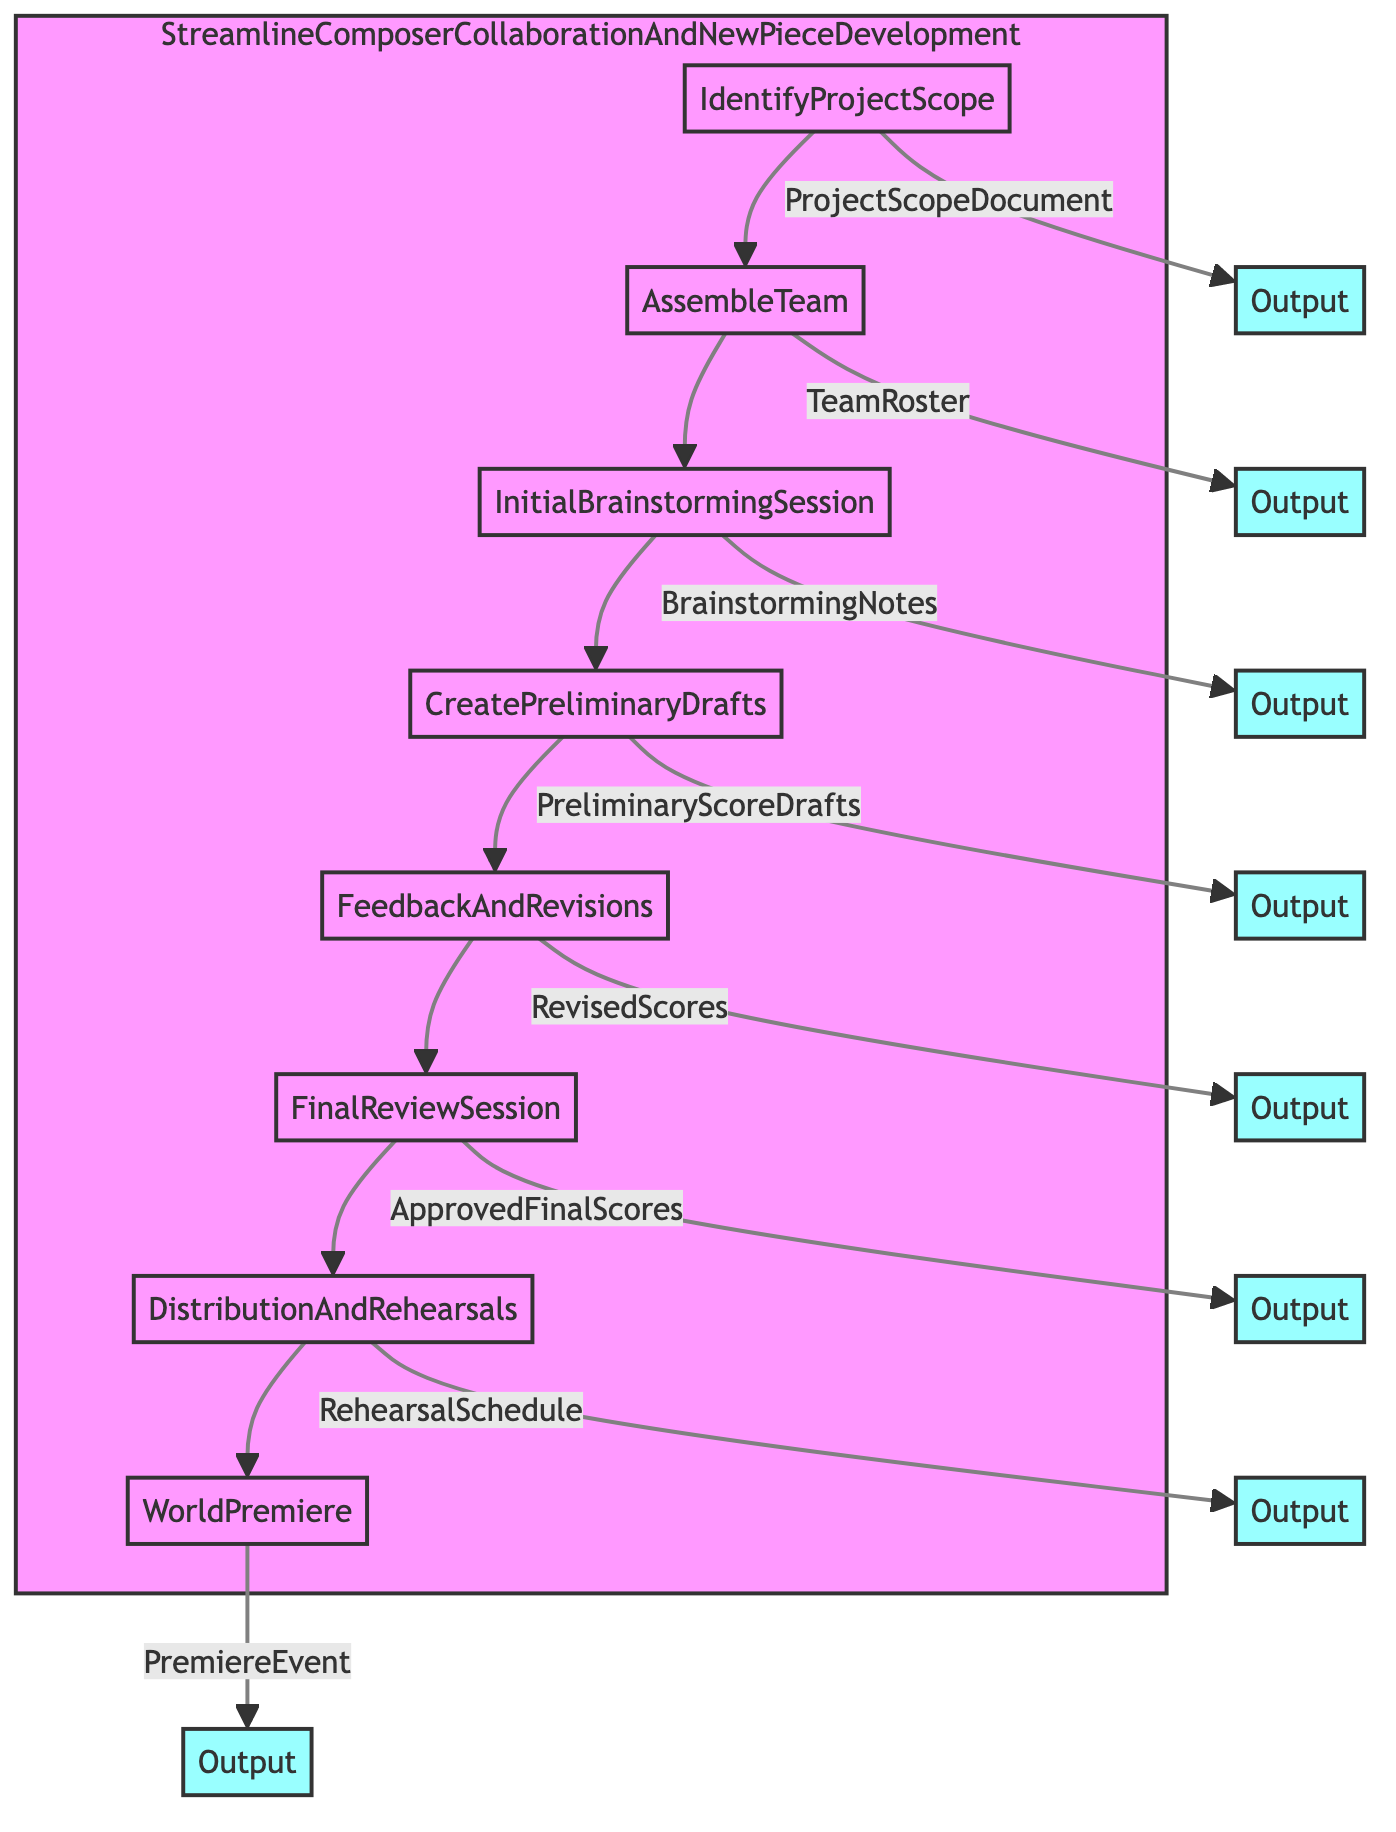What is the first step in the process? The first step in the process, as indicated by the flowchart, is "IdentifyProjectScope."
Answer: IdentifyProjectScope How many total steps are in the process? By counting all the steps listed in the flowchart, we find there are eight total steps: IdentifyProjectScope, AssembleTeam, InitialBrainstormingSession, CreatePreliminaryDrafts, FeedbackAndRevisions, FinalReviewSession, DistributionAndRehearsals, and WorldPremiere.
Answer: 8 What output follows the "FeedbackAndRevisions" step? According to the flowchart, the output that follows the "FeedbackAndRevisions" step is "RevisedScores."
Answer: RevisedScores Which entities are involved in the "InitialBrainstormingSession"? The flowchart specifies that the entities involved in the "InitialBrainstormingSession" are "Composer A," "Composer B," and "Selected Musicians."
Answer: Composer A, Composer B, Selected Musicians What is the relationship between "CreatePreliminaryDrafts" and "FinalReviewSession"? The relationship is sequential; "CreatePreliminaryDrafts" leads to the "FeedbackAndRevisions," which then leads to the "FinalReviewSession."
Answer: Sequential relationship List all outputs in the process. The outputs identified from the flowchart include: ProjectScopeDocument, TeamRoster, BrainstormingNotes, PreliminaryScoreDrafts, RevisedScores, ApprovedFinalScores, RehearsalSchedule, and PremiereEvent.
Answer: ProjectScopeDocument, TeamRoster, BrainstormingNotes, PreliminaryScoreDrafts, RevisedScores, ApprovedFinalScores, RehearsalSchedule, PremiereEvent Which entity is associated with the last step, "WorldPremiere"? The flowchart shows that the entities associated with the last step, "WorldPremiere," are "Event Planners," "Media Partners," and "Venue Management."
Answer: Event Planners, Media Partners, Venue Management What step immediately follows "DistributionAndRehearsals"? According to the flowchart, the step that immediately follows "DistributionAndRehearsals" is "WorldPremiere."
Answer: WorldPremiere What is the main purpose of the "FeedbackAndRevisions" step? The main purpose of the "FeedbackAndRevisions" step, as indicated in the flowchart, is to review drafts with team members and revise based on feedback.
Answer: Review and revise drafts 